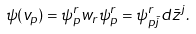<formula> <loc_0><loc_0><loc_500><loc_500>\psi ( v _ { p } ) = \psi ^ { r } _ { p } w _ { r } \psi ^ { r } _ { p } = \psi ^ { r } _ { p \bar { j } } d \bar { z } ^ { j } .</formula> 